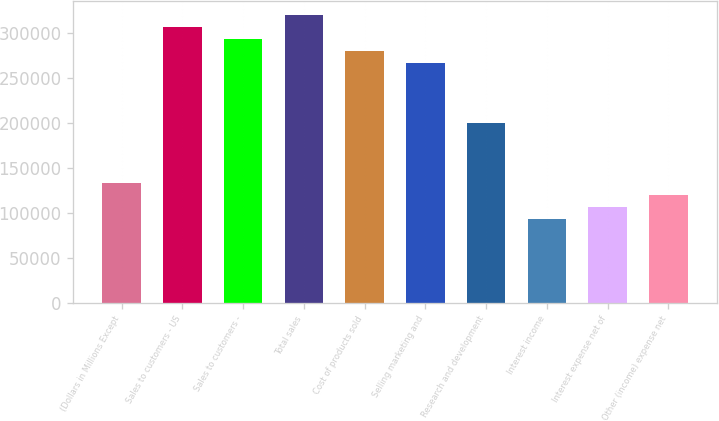<chart> <loc_0><loc_0><loc_500><loc_500><bar_chart><fcel>(Dollars in Millions Except<fcel>Sales to customers - US<fcel>Sales to customers -<fcel>Total sales<fcel>Cost of products sold<fcel>Selling marketing and<fcel>Research and development<fcel>Interest income<fcel>Interest expense net of<fcel>Other (income) expense net<nl><fcel>133411<fcel>306842<fcel>293501<fcel>320182<fcel>280160<fcel>266819<fcel>200115<fcel>93388.6<fcel>106729<fcel>120070<nl></chart> 